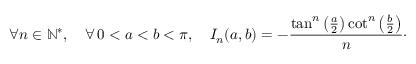<formula> <loc_0><loc_0><loc_500><loc_500>\forall n \in \mathbb { N } ^ { * } , \quad \forall \, 0 < a < b < \pi , \quad I _ { n } ( a , b ) = - \frac { \tan ^ { n } \left ( \frac { a } { 2 } \right ) \cot ^ { n } \left ( \frac { b } { 2 } \right ) } { n } \cdot</formula> 